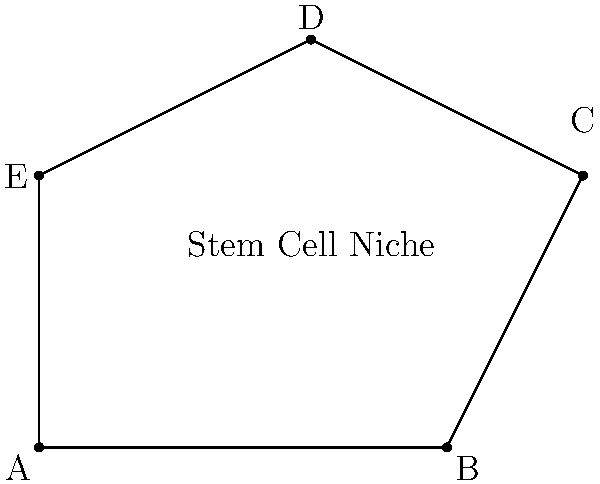A polygonal region representing a stem cell niche in tissue is shown above. The coordinates of the vertices are A(0,0), B(6,0), C(8,4), D(4,6), and E(0,4). Calculate the area of this stem cell niche in square units. To calculate the area of this irregular polygon, we can use the Shoelace formula (also known as the surveyor's formula). The steps are as follows:

1) The Shoelace formula for a polygon with vertices $(x_1, y_1), (x_2, y_2), ..., (x_n, y_n)$ is:

   Area = $\frac{1}{2}|((x_1y_2 + x_2y_3 + ... + x_ny_1) - (y_1x_2 + y_2x_3 + ... + y_nx_1))|$

2) For our polygon:
   A(0,0), B(6,0), C(8,4), D(4,6), E(0,4)

3) Applying the formula:

   Area = $\frac{1}{2}|((0 \cdot 0 + 6 \cdot 4 + 8 \cdot 6 + 4 \cdot 4 + 0 \cdot 0) - (0 \cdot 6 + 0 \cdot 8 + 4 \cdot 4 + 6 \cdot 0 + 4 \cdot 0))|$

4) Simplifying:
   
   Area = $\frac{1}{2}|(24 + 48 + 16) - (16)|$
   
   Area = $\frac{1}{2}|(88) - (16)|$
   
   Area = $\frac{1}{2}|72|$
   
   Area = $36$

Therefore, the area of the stem cell niche is 36 square units.
Answer: 36 square units 